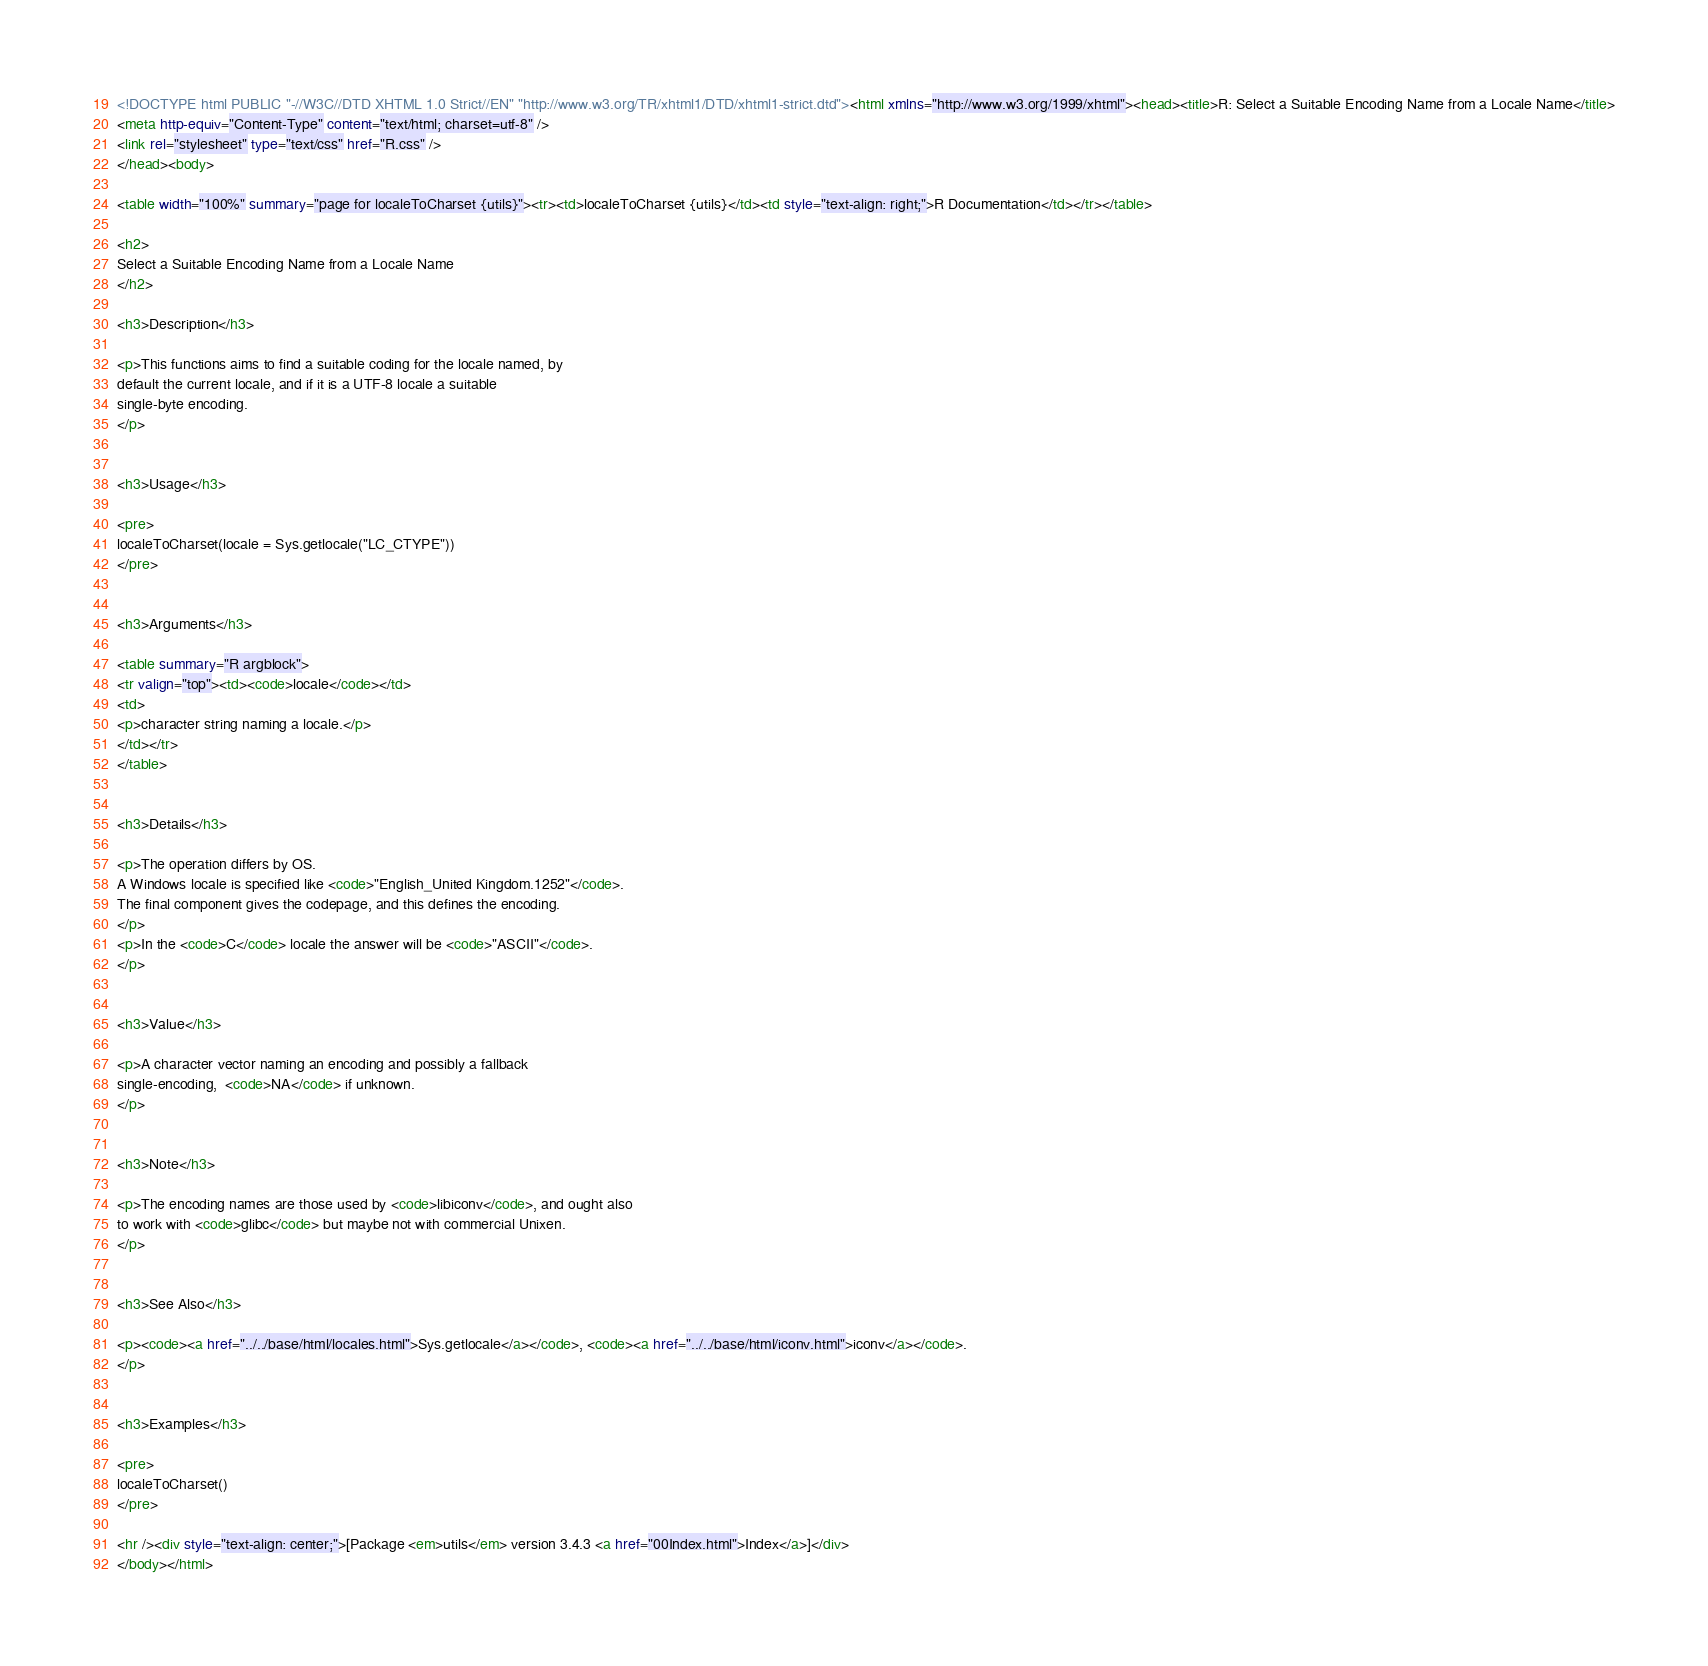Convert code to text. <code><loc_0><loc_0><loc_500><loc_500><_HTML_><!DOCTYPE html PUBLIC "-//W3C//DTD XHTML 1.0 Strict//EN" "http://www.w3.org/TR/xhtml1/DTD/xhtml1-strict.dtd"><html xmlns="http://www.w3.org/1999/xhtml"><head><title>R: Select a Suitable Encoding Name from a Locale Name</title>
<meta http-equiv="Content-Type" content="text/html; charset=utf-8" />
<link rel="stylesheet" type="text/css" href="R.css" />
</head><body>

<table width="100%" summary="page for localeToCharset {utils}"><tr><td>localeToCharset {utils}</td><td style="text-align: right;">R Documentation</td></tr></table>

<h2>
Select a Suitable Encoding Name from a Locale Name
</h2>

<h3>Description</h3>

<p>This functions aims to find a suitable coding for the locale named, by
default the current locale, and if it is a UTF-8 locale a suitable
single-byte encoding.
</p>


<h3>Usage</h3>

<pre>
localeToCharset(locale = Sys.getlocale("LC_CTYPE"))
</pre>


<h3>Arguments</h3>

<table summary="R argblock">
<tr valign="top"><td><code>locale</code></td>
<td>
<p>character string naming a locale.</p>
</td></tr>
</table>


<h3>Details</h3>

<p>The operation differs by OS.
A Windows locale is specified like <code>"English_United Kingdom.1252"</code>.
The final component gives the codepage, and this defines the encoding.
</p>
<p>In the <code>C</code> locale the answer will be <code>"ASCII"</code>.
</p>


<h3>Value</h3>

<p>A character vector naming an encoding and possibly a fallback
single-encoding,  <code>NA</code> if unknown.
</p>


<h3>Note</h3>

<p>The encoding names are those used by <code>libiconv</code>, and ought also
to work with <code>glibc</code> but maybe not with commercial Unixen.
</p>


<h3>See Also</h3>

<p><code><a href="../../base/html/locales.html">Sys.getlocale</a></code>, <code><a href="../../base/html/iconv.html">iconv</a></code>.
</p>


<h3>Examples</h3>

<pre>
localeToCharset()
</pre>

<hr /><div style="text-align: center;">[Package <em>utils</em> version 3.4.3 <a href="00Index.html">Index</a>]</div>
</body></html>
</code> 